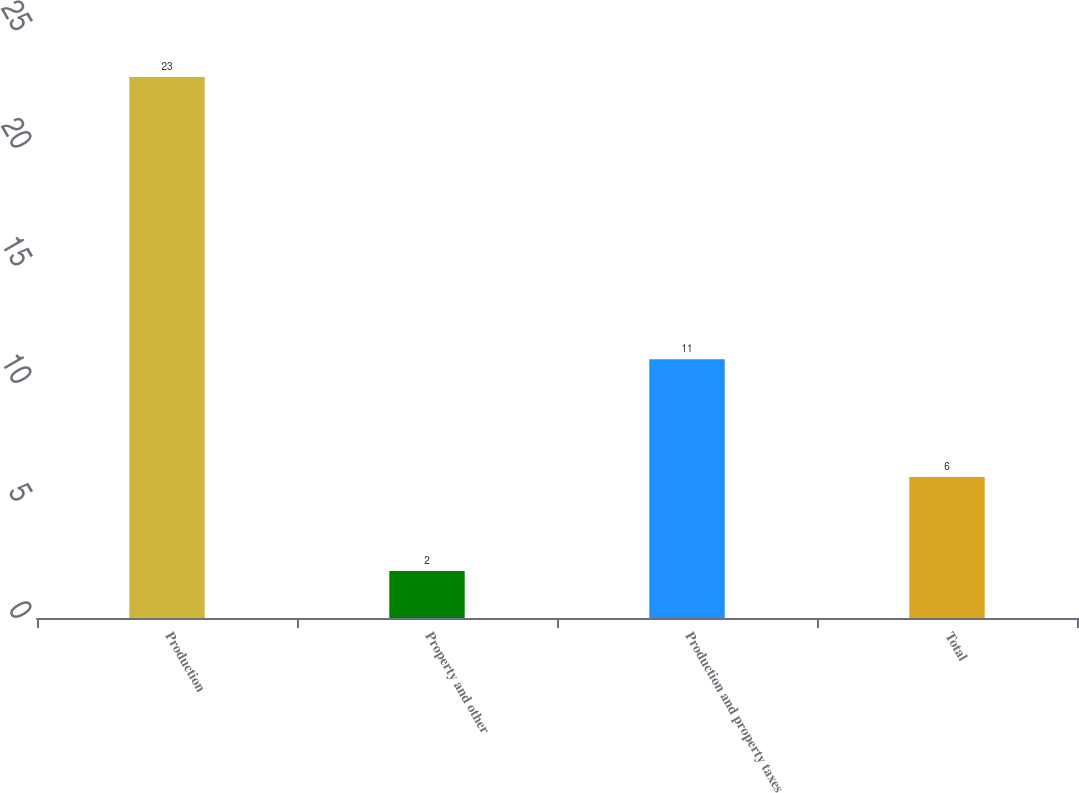Convert chart. <chart><loc_0><loc_0><loc_500><loc_500><bar_chart><fcel>Production<fcel>Property and other<fcel>Production and property taxes<fcel>Total<nl><fcel>23<fcel>2<fcel>11<fcel>6<nl></chart> 